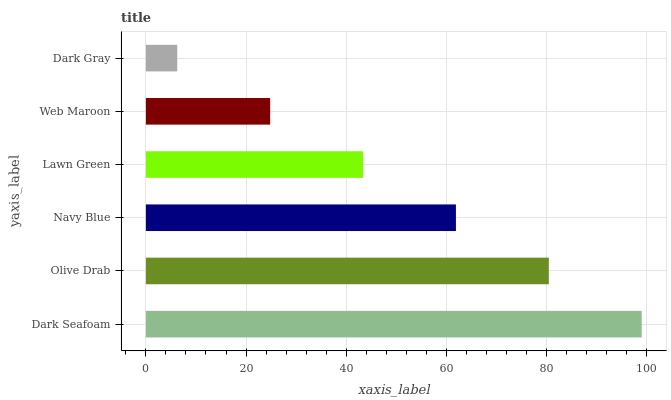Is Dark Gray the minimum?
Answer yes or no. Yes. Is Dark Seafoam the maximum?
Answer yes or no. Yes. Is Olive Drab the minimum?
Answer yes or no. No. Is Olive Drab the maximum?
Answer yes or no. No. Is Dark Seafoam greater than Olive Drab?
Answer yes or no. Yes. Is Olive Drab less than Dark Seafoam?
Answer yes or no. Yes. Is Olive Drab greater than Dark Seafoam?
Answer yes or no. No. Is Dark Seafoam less than Olive Drab?
Answer yes or no. No. Is Navy Blue the high median?
Answer yes or no. Yes. Is Lawn Green the low median?
Answer yes or no. Yes. Is Dark Seafoam the high median?
Answer yes or no. No. Is Olive Drab the low median?
Answer yes or no. No. 